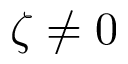Convert formula to latex. <formula><loc_0><loc_0><loc_500><loc_500>\zeta \neq 0</formula> 